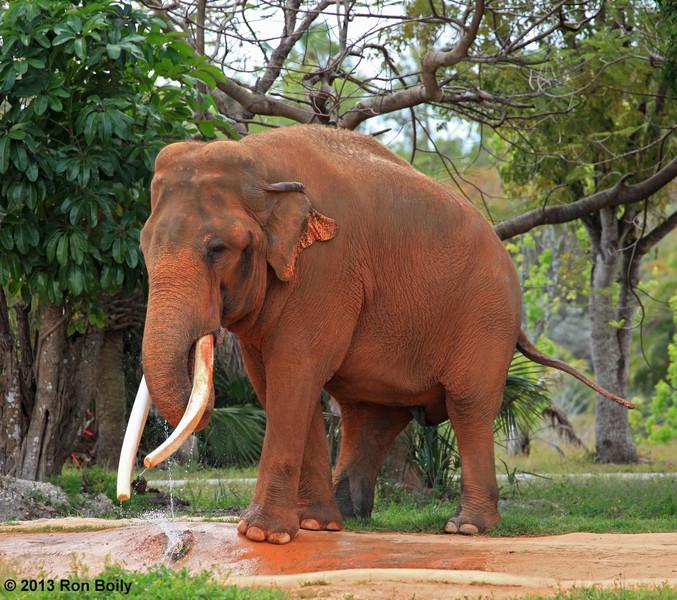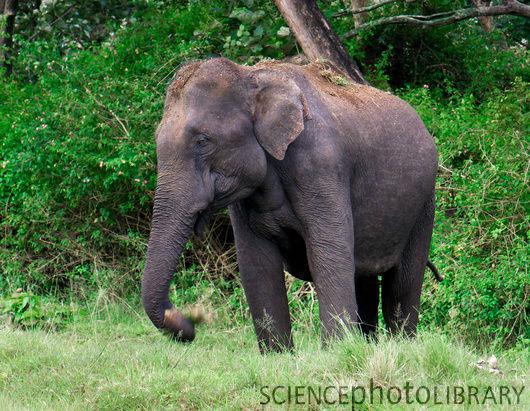The first image is the image on the left, the second image is the image on the right. Considering the images on both sides, is "The left image includes an elephant with tusks, but the right image contains only a tuskless elephant." valid? Answer yes or no. Yes. The first image is the image on the left, the second image is the image on the right. For the images displayed, is the sentence "The elephant in the right image is walking towards the right." factually correct? Answer yes or no. No. 